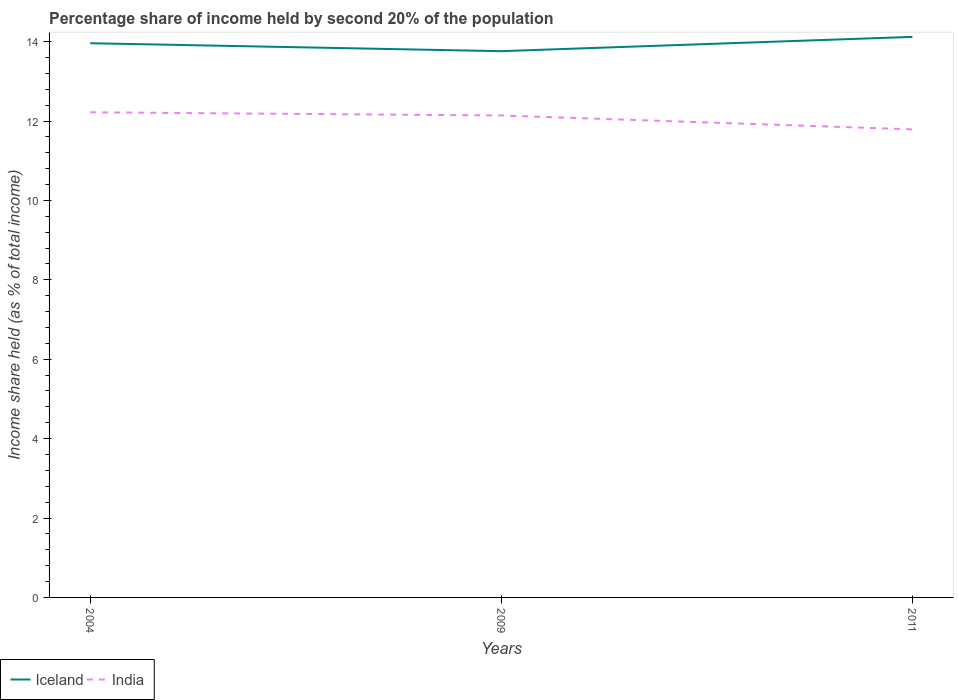How many different coloured lines are there?
Provide a succinct answer. 2. Does the line corresponding to India intersect with the line corresponding to Iceland?
Your answer should be very brief. No. Across all years, what is the maximum share of income held by second 20% of the population in Iceland?
Offer a terse response. 13.76. In which year was the share of income held by second 20% of the population in Iceland maximum?
Offer a very short reply. 2009. What is the total share of income held by second 20% of the population in India in the graph?
Offer a very short reply. 0.08. What is the difference between the highest and the second highest share of income held by second 20% of the population in Iceland?
Provide a succinct answer. 0.36. What is the difference between the highest and the lowest share of income held by second 20% of the population in Iceland?
Provide a succinct answer. 2. How many lines are there?
Provide a short and direct response. 2. Does the graph contain grids?
Make the answer very short. No. Where does the legend appear in the graph?
Keep it short and to the point. Bottom left. How many legend labels are there?
Make the answer very short. 2. What is the title of the graph?
Your answer should be very brief. Percentage share of income held by second 20% of the population. Does "South Sudan" appear as one of the legend labels in the graph?
Keep it short and to the point. No. What is the label or title of the Y-axis?
Provide a short and direct response. Income share held (as % of total income). What is the Income share held (as % of total income) of Iceland in 2004?
Your response must be concise. 13.96. What is the Income share held (as % of total income) of India in 2004?
Your response must be concise. 12.22. What is the Income share held (as % of total income) in Iceland in 2009?
Provide a short and direct response. 13.76. What is the Income share held (as % of total income) of India in 2009?
Offer a very short reply. 12.14. What is the Income share held (as % of total income) in Iceland in 2011?
Ensure brevity in your answer.  14.12. What is the Income share held (as % of total income) of India in 2011?
Provide a short and direct response. 11.79. Across all years, what is the maximum Income share held (as % of total income) of Iceland?
Offer a terse response. 14.12. Across all years, what is the maximum Income share held (as % of total income) in India?
Provide a succinct answer. 12.22. Across all years, what is the minimum Income share held (as % of total income) in Iceland?
Your answer should be compact. 13.76. Across all years, what is the minimum Income share held (as % of total income) in India?
Make the answer very short. 11.79. What is the total Income share held (as % of total income) of Iceland in the graph?
Make the answer very short. 41.84. What is the total Income share held (as % of total income) of India in the graph?
Make the answer very short. 36.15. What is the difference between the Income share held (as % of total income) in Iceland in 2004 and that in 2009?
Your answer should be very brief. 0.2. What is the difference between the Income share held (as % of total income) in Iceland in 2004 and that in 2011?
Make the answer very short. -0.16. What is the difference between the Income share held (as % of total income) in India in 2004 and that in 2011?
Your answer should be very brief. 0.43. What is the difference between the Income share held (as % of total income) in Iceland in 2009 and that in 2011?
Offer a terse response. -0.36. What is the difference between the Income share held (as % of total income) of Iceland in 2004 and the Income share held (as % of total income) of India in 2009?
Keep it short and to the point. 1.82. What is the difference between the Income share held (as % of total income) in Iceland in 2004 and the Income share held (as % of total income) in India in 2011?
Offer a very short reply. 2.17. What is the difference between the Income share held (as % of total income) of Iceland in 2009 and the Income share held (as % of total income) of India in 2011?
Keep it short and to the point. 1.97. What is the average Income share held (as % of total income) of Iceland per year?
Provide a short and direct response. 13.95. What is the average Income share held (as % of total income) in India per year?
Make the answer very short. 12.05. In the year 2004, what is the difference between the Income share held (as % of total income) of Iceland and Income share held (as % of total income) of India?
Your response must be concise. 1.74. In the year 2009, what is the difference between the Income share held (as % of total income) in Iceland and Income share held (as % of total income) in India?
Make the answer very short. 1.62. In the year 2011, what is the difference between the Income share held (as % of total income) of Iceland and Income share held (as % of total income) of India?
Keep it short and to the point. 2.33. What is the ratio of the Income share held (as % of total income) in Iceland in 2004 to that in 2009?
Ensure brevity in your answer.  1.01. What is the ratio of the Income share held (as % of total income) in India in 2004 to that in 2009?
Give a very brief answer. 1.01. What is the ratio of the Income share held (as % of total income) of Iceland in 2004 to that in 2011?
Give a very brief answer. 0.99. What is the ratio of the Income share held (as % of total income) of India in 2004 to that in 2011?
Your answer should be very brief. 1.04. What is the ratio of the Income share held (as % of total income) in Iceland in 2009 to that in 2011?
Ensure brevity in your answer.  0.97. What is the ratio of the Income share held (as % of total income) of India in 2009 to that in 2011?
Give a very brief answer. 1.03. What is the difference between the highest and the second highest Income share held (as % of total income) in Iceland?
Provide a short and direct response. 0.16. What is the difference between the highest and the lowest Income share held (as % of total income) of Iceland?
Your answer should be compact. 0.36. What is the difference between the highest and the lowest Income share held (as % of total income) in India?
Your response must be concise. 0.43. 